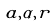<formula> <loc_0><loc_0><loc_500><loc_500>a , \alpha , r</formula> 